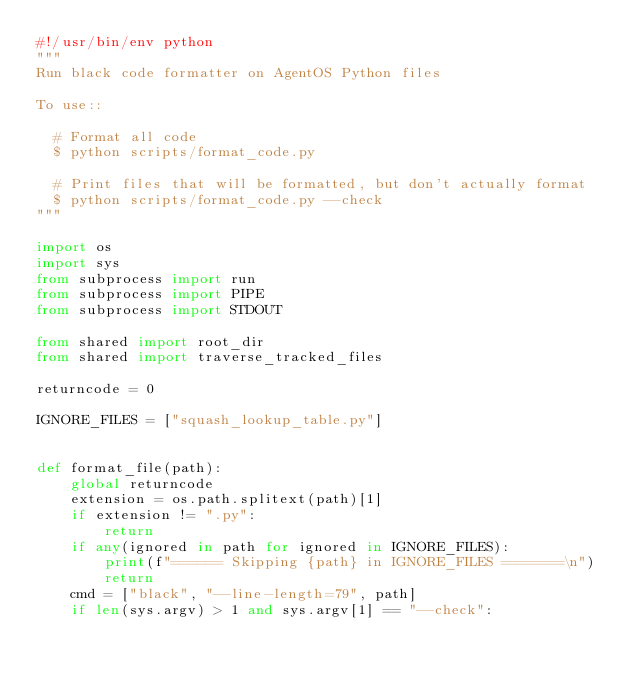Convert code to text. <code><loc_0><loc_0><loc_500><loc_500><_Python_>#!/usr/bin/env python
"""
Run black code formatter on AgentOS Python files

To use::

  # Format all code
  $ python scripts/format_code.py

  # Print files that will be formatted, but don't actually format
  $ python scripts/format_code.py --check
"""

import os
import sys
from subprocess import run
from subprocess import PIPE
from subprocess import STDOUT

from shared import root_dir
from shared import traverse_tracked_files

returncode = 0

IGNORE_FILES = ["squash_lookup_table.py"]


def format_file(path):
    global returncode
    extension = os.path.splitext(path)[1]
    if extension != ".py":
        return
    if any(ignored in path for ignored in IGNORE_FILES):
        print(f"====== Skipping {path} in IGNORE_FILES =======\n")
        return
    cmd = ["black", "--line-length=79", path]
    if len(sys.argv) > 1 and sys.argv[1] == "--check":</code> 